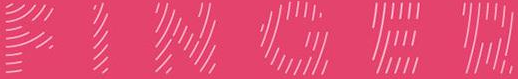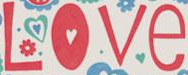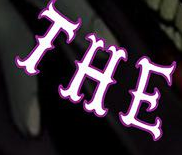What text is displayed in these images sequentially, separated by a semicolon? FINGER; Love; THE 